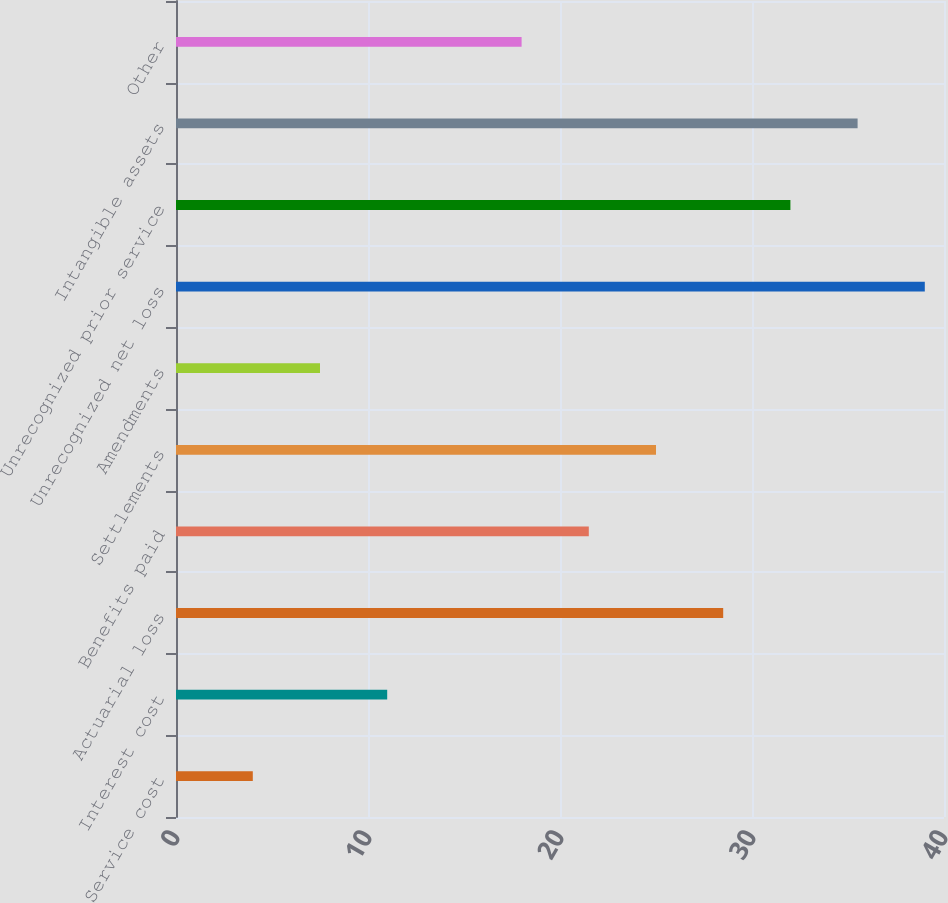<chart> <loc_0><loc_0><loc_500><loc_500><bar_chart><fcel>Service cost<fcel>Interest cost<fcel>Actuarial loss<fcel>Benefits paid<fcel>Settlements<fcel>Amendments<fcel>Unrecognized net loss<fcel>Unrecognized prior service<fcel>Intangible assets<fcel>Other<nl><fcel>4<fcel>11<fcel>28.5<fcel>21.5<fcel>25<fcel>7.5<fcel>39<fcel>32<fcel>35.5<fcel>18<nl></chart> 